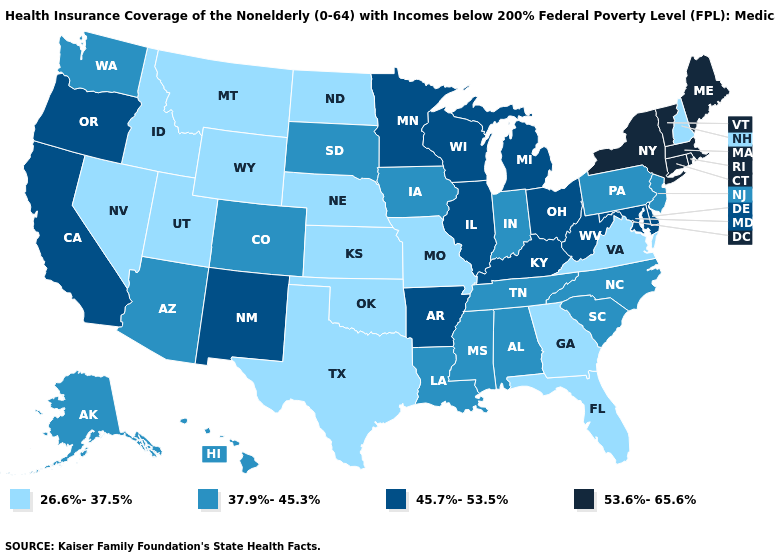Among the states that border Minnesota , does Wisconsin have the highest value?
Give a very brief answer. Yes. What is the highest value in the USA?
Concise answer only. 53.6%-65.6%. Does Montana have the lowest value in the USA?
Write a very short answer. Yes. Does Alabama have a higher value than Pennsylvania?
Answer briefly. No. What is the lowest value in states that border North Dakota?
Give a very brief answer. 26.6%-37.5%. Which states hav the highest value in the West?
Quick response, please. California, New Mexico, Oregon. Does Pennsylvania have the lowest value in the Northeast?
Give a very brief answer. No. Among the states that border Colorado , does New Mexico have the lowest value?
Quick response, please. No. Which states have the lowest value in the USA?
Short answer required. Florida, Georgia, Idaho, Kansas, Missouri, Montana, Nebraska, Nevada, New Hampshire, North Dakota, Oklahoma, Texas, Utah, Virginia, Wyoming. Name the states that have a value in the range 45.7%-53.5%?
Write a very short answer. Arkansas, California, Delaware, Illinois, Kentucky, Maryland, Michigan, Minnesota, New Mexico, Ohio, Oregon, West Virginia, Wisconsin. Among the states that border Vermont , which have the highest value?
Answer briefly. Massachusetts, New York. Name the states that have a value in the range 53.6%-65.6%?
Keep it brief. Connecticut, Maine, Massachusetts, New York, Rhode Island, Vermont. Does Texas have the lowest value in the USA?
Concise answer only. Yes. Name the states that have a value in the range 26.6%-37.5%?
Keep it brief. Florida, Georgia, Idaho, Kansas, Missouri, Montana, Nebraska, Nevada, New Hampshire, North Dakota, Oklahoma, Texas, Utah, Virginia, Wyoming. 